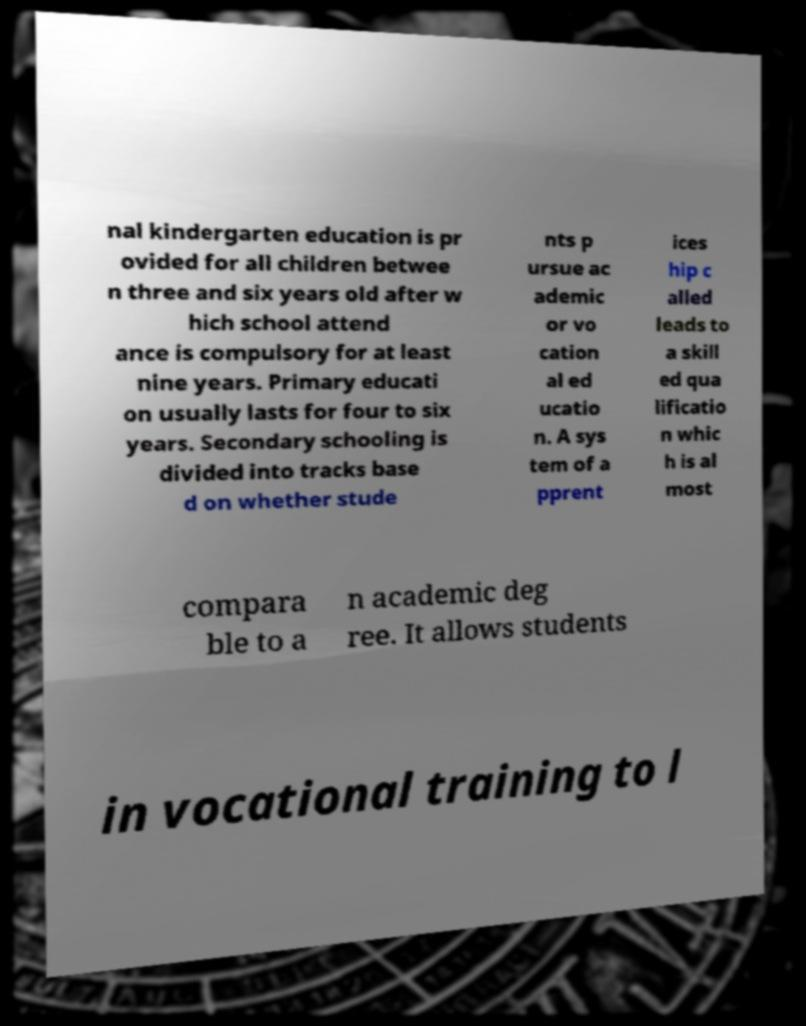For documentation purposes, I need the text within this image transcribed. Could you provide that? nal kindergarten education is pr ovided for all children betwee n three and six years old after w hich school attend ance is compulsory for at least nine years. Primary educati on usually lasts for four to six years. Secondary schooling is divided into tracks base d on whether stude nts p ursue ac ademic or vo cation al ed ucatio n. A sys tem of a pprent ices hip c alled leads to a skill ed qua lificatio n whic h is al most compara ble to a n academic deg ree. It allows students in vocational training to l 